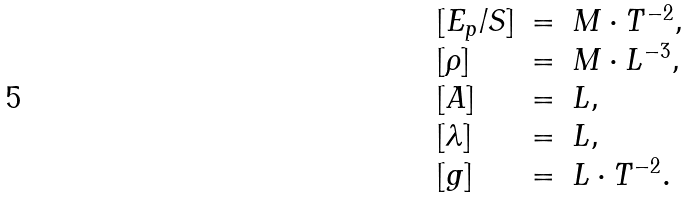<formula> <loc_0><loc_0><loc_500><loc_500>\begin{array} { l c l } [ E _ { p } / S ] & = & M \cdot T ^ { - 2 } , \\ { [ \rho ] } & = & M \cdot L ^ { - 3 } , \\ { [ A ] } & = & L , \\ { [ \lambda ] } & = & L , \\ { [ g ] } & = & L \cdot T ^ { - 2 } . \end{array}</formula> 